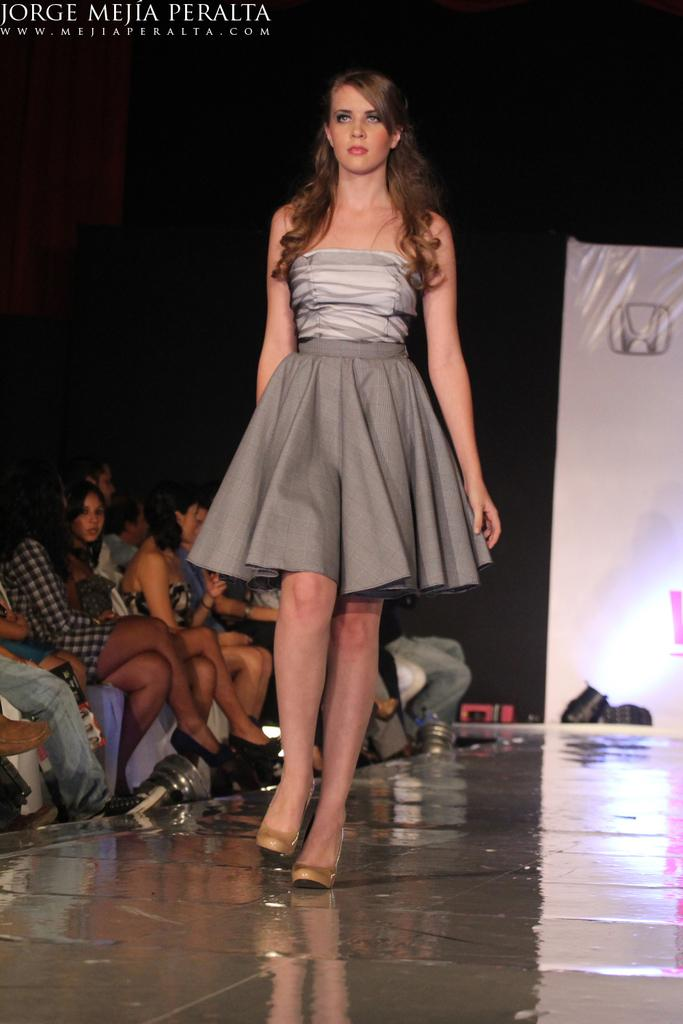Who is the main subject in the image? There is a woman in the image. What is the woman doing in the image? The woman is walking. What is the woman wearing in the image? The woman is wearing a grey color frock. What can be seen on the left side of the image? There are persons sitting on the left side of the image. What is present on the right side of the image? There is a banner on the right side of the image. Can you tell me how many zebras are present in the image? There are no zebras present in the image. What type of umbrella is the woman holding in the image? The woman is not holding an umbrella in the image. 